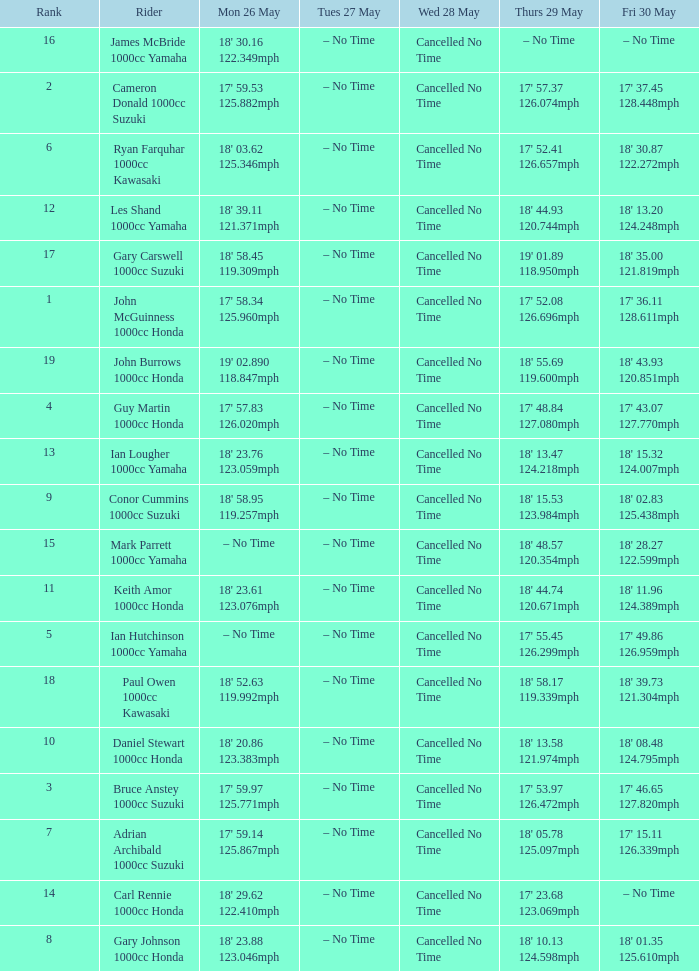What time is mon may 26 and fri may 30 is 18' 28.27 122.599mph? – No Time. 